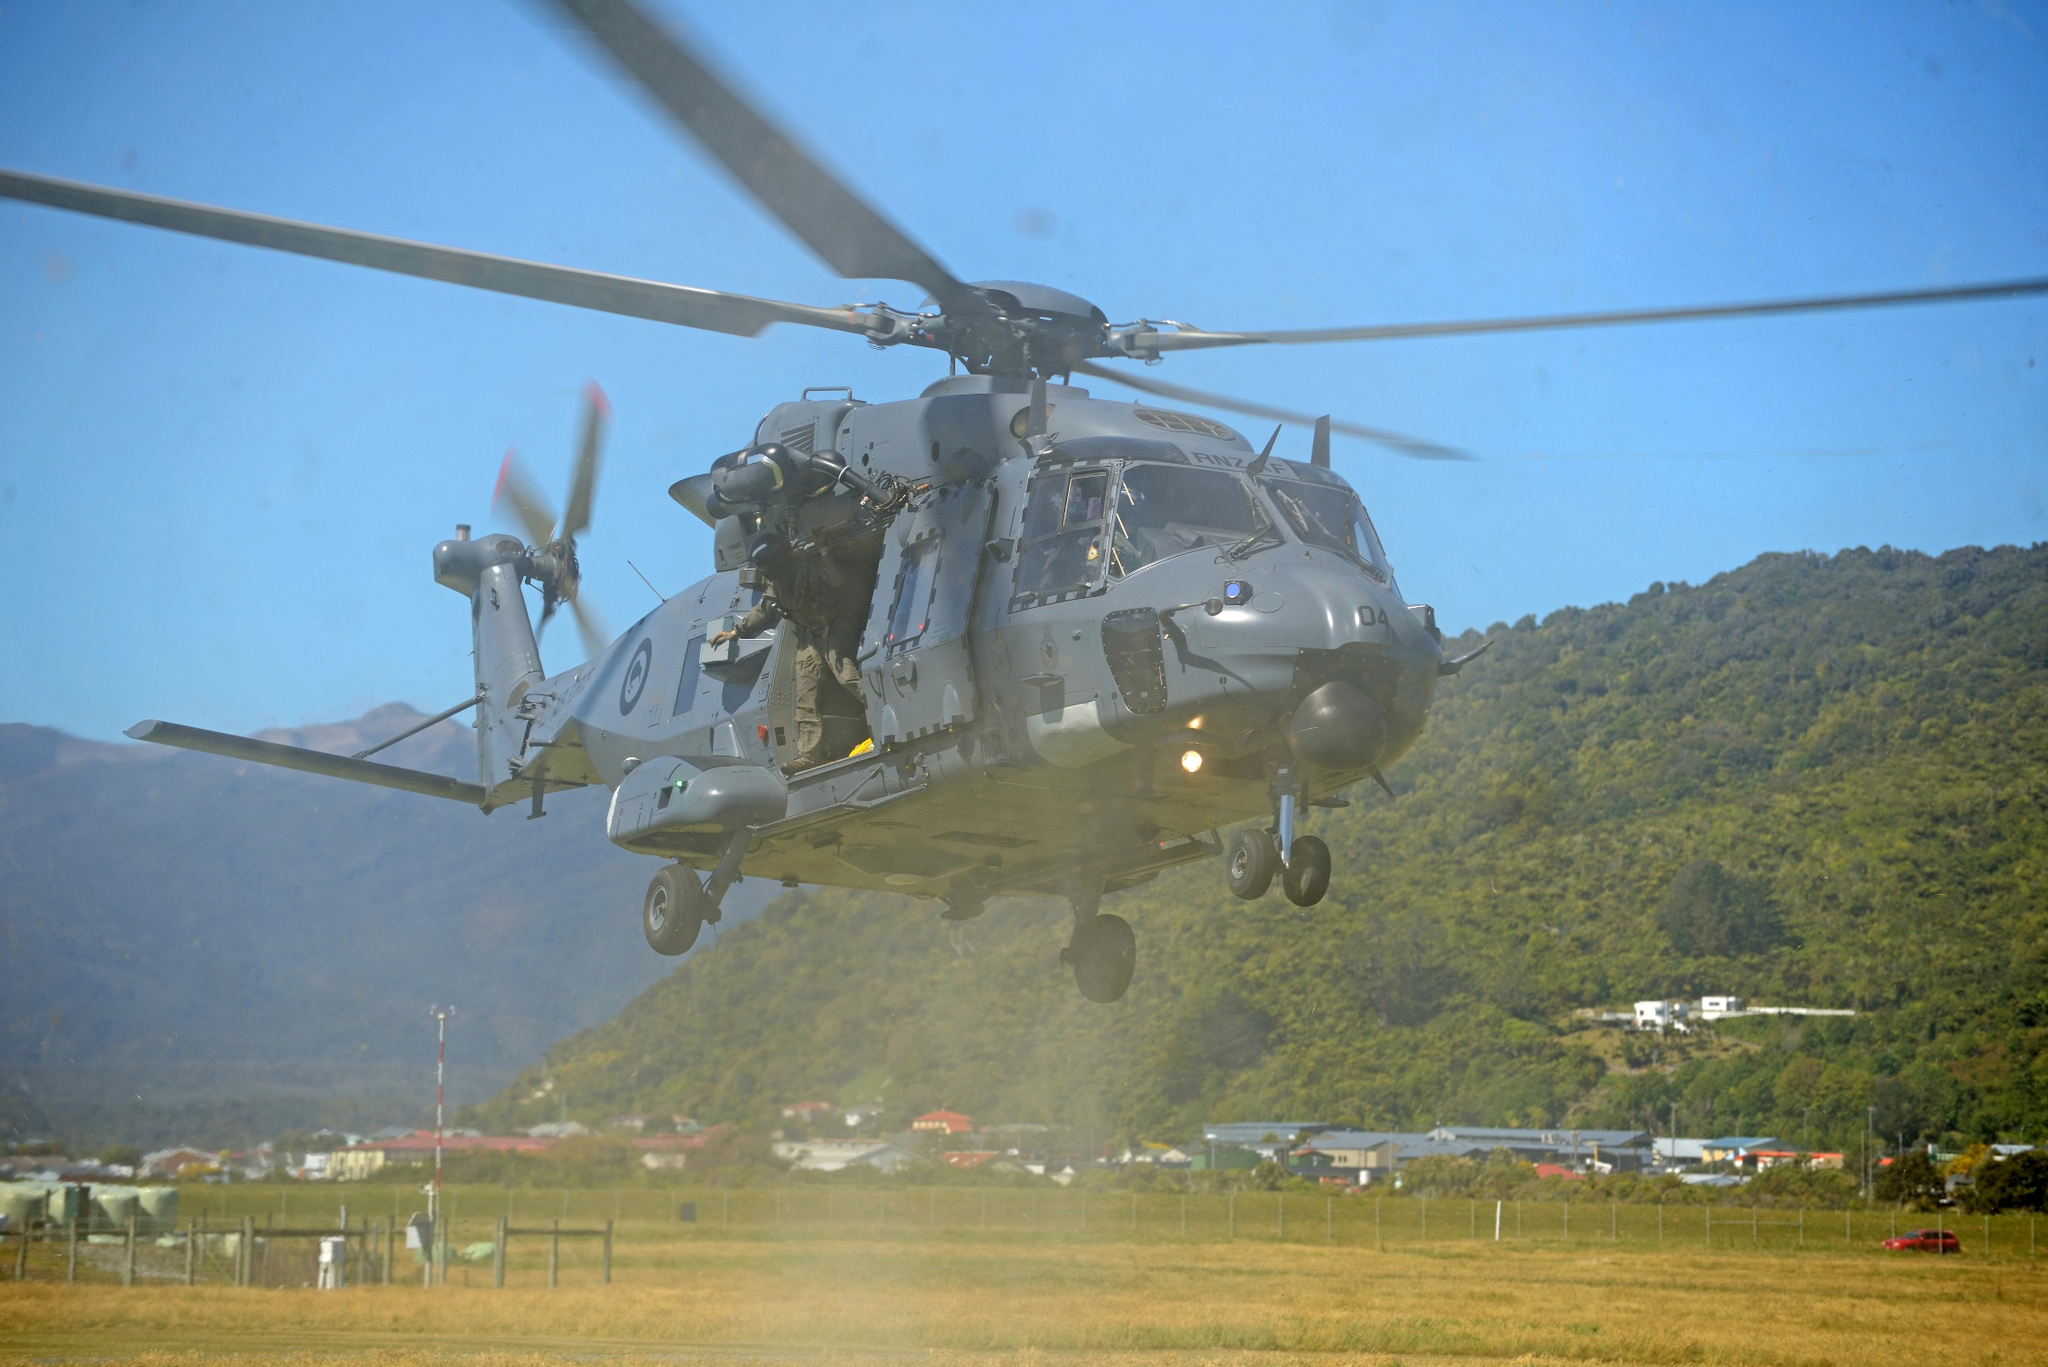Can you tell what kind of mission the helicopter might be on? Given the military nature of the helicopter, it could be engaged in a variety of missions such as reconnaissance, transport, search and rescue, or even a training exercise. The presence of personnel on board who appear to be in action suggests a potentially dynamic operation, requiring quick maneuverability and tactical precision. What are some possible destinations one could infer from the image landscape? The landscape, featuring a lush green field and distant mountain ranges, could suggest several possible destinations. The helicopter might be heading to a remote mountain outpost, a military base located in a rural area, or engaging in a patrol or survey mission over natural terrain to monitor or safeguard the region. Imagine the time of day this scene likely depicts. Based on the bright and clear blue sky, it seems likely that this scene is captured during daylight hours, possibly late morning or early afternoon when the sun is high and the light is optimal for visibility. The overall lighting and shadows suggest a time when the environment is well-illuminated, enhancing the clarity of the details in the image. 